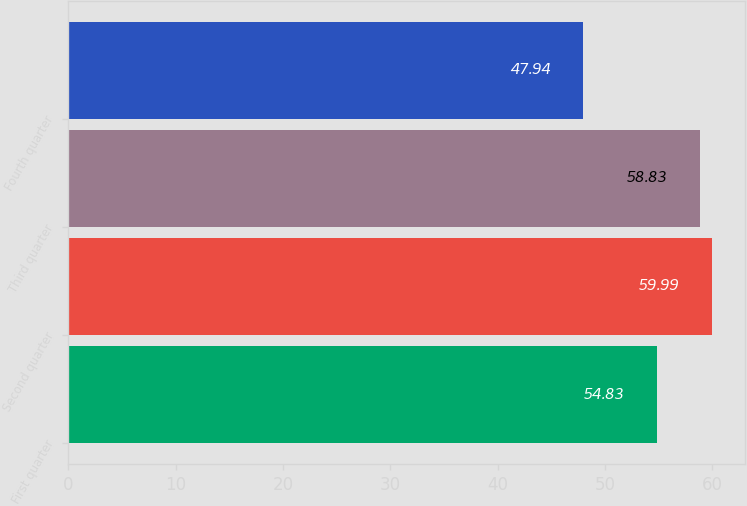Convert chart to OTSL. <chart><loc_0><loc_0><loc_500><loc_500><bar_chart><fcel>First quarter<fcel>Second quarter<fcel>Third quarter<fcel>Fourth quarter<nl><fcel>54.83<fcel>59.99<fcel>58.83<fcel>47.94<nl></chart> 